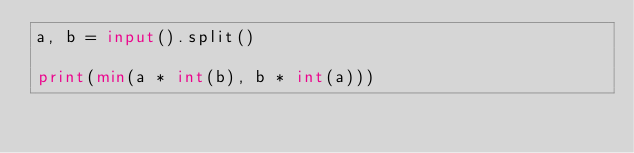Convert code to text. <code><loc_0><loc_0><loc_500><loc_500><_Python_>a, b = input().split()

print(min(a * int(b), b * int(a)))</code> 